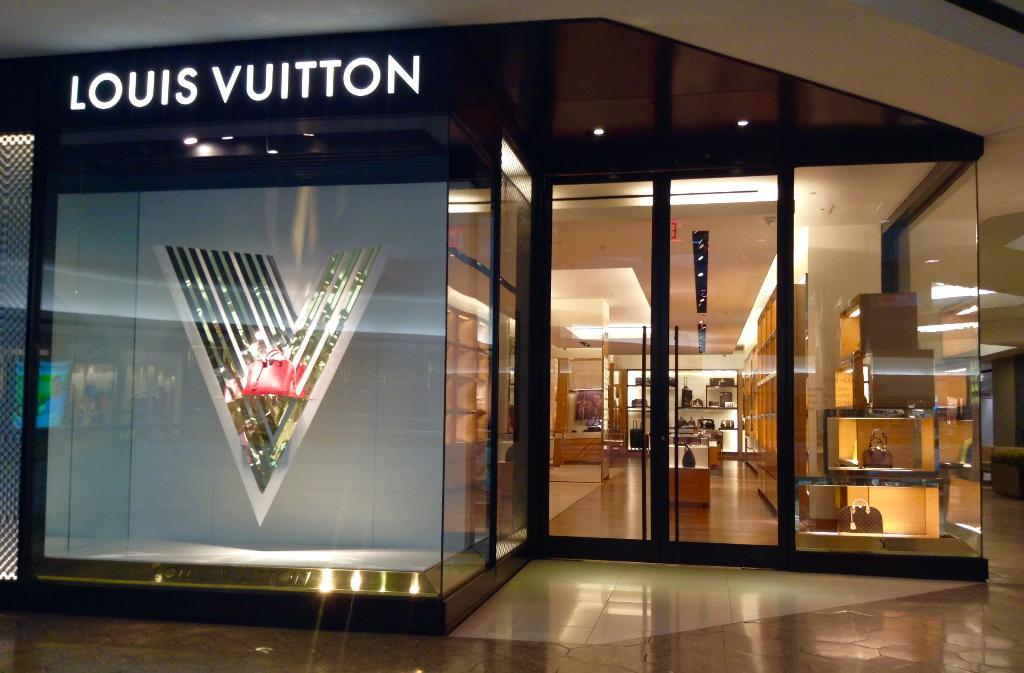Provide a one-sentence caption for the provided image. The outside of  a Louis Vuitton store, with glass windows and doors. 